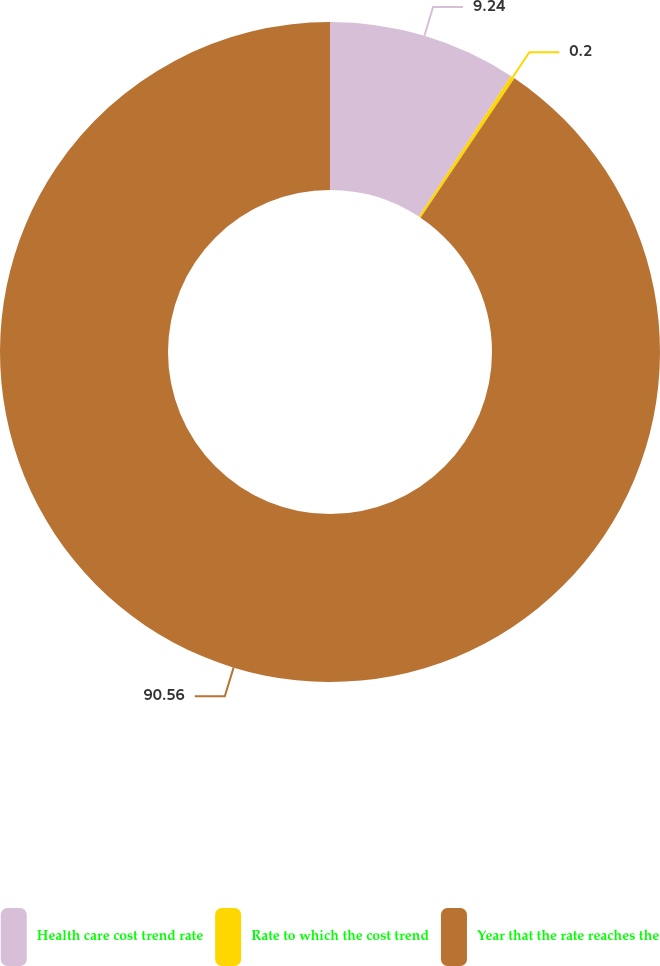Convert chart. <chart><loc_0><loc_0><loc_500><loc_500><pie_chart><fcel>Health care cost trend rate<fcel>Rate to which the cost trend<fcel>Year that the rate reaches the<nl><fcel>9.24%<fcel>0.2%<fcel>90.56%<nl></chart> 